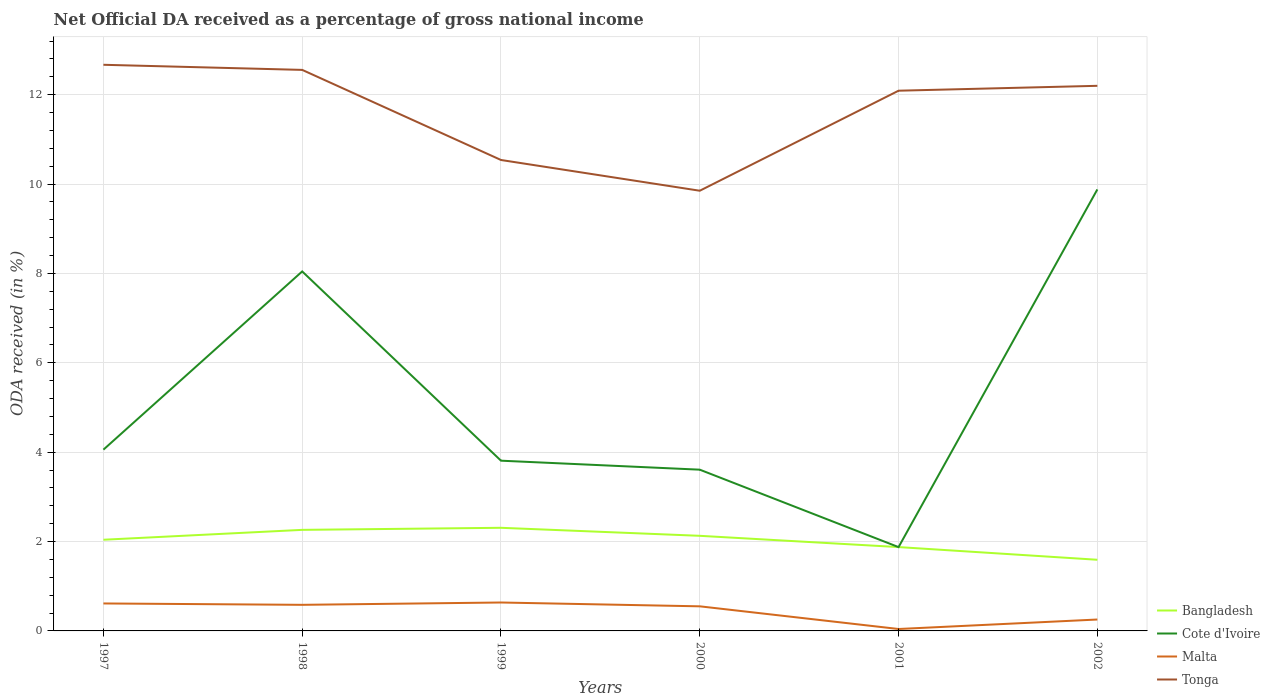Is the number of lines equal to the number of legend labels?
Make the answer very short. Yes. Across all years, what is the maximum net official DA received in Cote d'Ivoire?
Give a very brief answer. 1.88. In which year was the net official DA received in Cote d'Ivoire maximum?
Your response must be concise. 2001. What is the total net official DA received in Tonga in the graph?
Offer a terse response. 0.11. What is the difference between the highest and the second highest net official DA received in Malta?
Provide a succinct answer. 0.59. What is the difference between the highest and the lowest net official DA received in Tonga?
Give a very brief answer. 4. Is the net official DA received in Cote d'Ivoire strictly greater than the net official DA received in Tonga over the years?
Your answer should be very brief. Yes. How many lines are there?
Provide a succinct answer. 4. How many years are there in the graph?
Make the answer very short. 6. Are the values on the major ticks of Y-axis written in scientific E-notation?
Give a very brief answer. No. Does the graph contain any zero values?
Provide a succinct answer. No. How many legend labels are there?
Keep it short and to the point. 4. How are the legend labels stacked?
Provide a succinct answer. Vertical. What is the title of the graph?
Ensure brevity in your answer.  Net Official DA received as a percentage of gross national income. Does "Lao PDR" appear as one of the legend labels in the graph?
Offer a very short reply. No. What is the label or title of the X-axis?
Give a very brief answer. Years. What is the label or title of the Y-axis?
Your answer should be very brief. ODA received (in %). What is the ODA received (in %) of Bangladesh in 1997?
Offer a very short reply. 2.04. What is the ODA received (in %) in Cote d'Ivoire in 1997?
Provide a succinct answer. 4.06. What is the ODA received (in %) of Malta in 1997?
Provide a succinct answer. 0.61. What is the ODA received (in %) in Tonga in 1997?
Your answer should be very brief. 12.67. What is the ODA received (in %) of Bangladesh in 1998?
Provide a succinct answer. 2.26. What is the ODA received (in %) in Cote d'Ivoire in 1998?
Make the answer very short. 8.05. What is the ODA received (in %) of Malta in 1998?
Give a very brief answer. 0.58. What is the ODA received (in %) of Tonga in 1998?
Ensure brevity in your answer.  12.56. What is the ODA received (in %) in Bangladesh in 1999?
Ensure brevity in your answer.  2.31. What is the ODA received (in %) of Cote d'Ivoire in 1999?
Provide a short and direct response. 3.81. What is the ODA received (in %) in Malta in 1999?
Your answer should be compact. 0.64. What is the ODA received (in %) in Tonga in 1999?
Offer a very short reply. 10.54. What is the ODA received (in %) of Bangladesh in 2000?
Give a very brief answer. 2.13. What is the ODA received (in %) in Cote d'Ivoire in 2000?
Make the answer very short. 3.61. What is the ODA received (in %) of Malta in 2000?
Ensure brevity in your answer.  0.55. What is the ODA received (in %) of Tonga in 2000?
Your response must be concise. 9.85. What is the ODA received (in %) of Bangladesh in 2001?
Your answer should be very brief. 1.88. What is the ODA received (in %) in Cote d'Ivoire in 2001?
Make the answer very short. 1.88. What is the ODA received (in %) of Malta in 2001?
Your answer should be very brief. 0.04. What is the ODA received (in %) of Tonga in 2001?
Provide a short and direct response. 12.09. What is the ODA received (in %) of Bangladesh in 2002?
Your response must be concise. 1.59. What is the ODA received (in %) in Cote d'Ivoire in 2002?
Your answer should be compact. 9.88. What is the ODA received (in %) in Malta in 2002?
Give a very brief answer. 0.26. What is the ODA received (in %) of Tonga in 2002?
Your response must be concise. 12.2. Across all years, what is the maximum ODA received (in %) of Bangladesh?
Offer a very short reply. 2.31. Across all years, what is the maximum ODA received (in %) in Cote d'Ivoire?
Ensure brevity in your answer.  9.88. Across all years, what is the maximum ODA received (in %) of Malta?
Make the answer very short. 0.64. Across all years, what is the maximum ODA received (in %) in Tonga?
Make the answer very short. 12.67. Across all years, what is the minimum ODA received (in %) of Bangladesh?
Make the answer very short. 1.59. Across all years, what is the minimum ODA received (in %) in Cote d'Ivoire?
Ensure brevity in your answer.  1.88. Across all years, what is the minimum ODA received (in %) of Malta?
Keep it short and to the point. 0.04. Across all years, what is the minimum ODA received (in %) of Tonga?
Ensure brevity in your answer.  9.85. What is the total ODA received (in %) in Bangladesh in the graph?
Keep it short and to the point. 12.21. What is the total ODA received (in %) in Cote d'Ivoire in the graph?
Offer a very short reply. 31.28. What is the total ODA received (in %) in Malta in the graph?
Provide a short and direct response. 2.68. What is the total ODA received (in %) of Tonga in the graph?
Make the answer very short. 69.9. What is the difference between the ODA received (in %) of Bangladesh in 1997 and that in 1998?
Your answer should be compact. -0.22. What is the difference between the ODA received (in %) of Cote d'Ivoire in 1997 and that in 1998?
Provide a succinct answer. -3.99. What is the difference between the ODA received (in %) in Malta in 1997 and that in 1998?
Your response must be concise. 0.03. What is the difference between the ODA received (in %) in Tonga in 1997 and that in 1998?
Your answer should be compact. 0.11. What is the difference between the ODA received (in %) in Bangladesh in 1997 and that in 1999?
Offer a terse response. -0.27. What is the difference between the ODA received (in %) of Cote d'Ivoire in 1997 and that in 1999?
Give a very brief answer. 0.25. What is the difference between the ODA received (in %) in Malta in 1997 and that in 1999?
Offer a very short reply. -0.02. What is the difference between the ODA received (in %) in Tonga in 1997 and that in 1999?
Offer a very short reply. 2.13. What is the difference between the ODA received (in %) in Bangladesh in 1997 and that in 2000?
Offer a terse response. -0.09. What is the difference between the ODA received (in %) of Cote d'Ivoire in 1997 and that in 2000?
Give a very brief answer. 0.45. What is the difference between the ODA received (in %) of Malta in 1997 and that in 2000?
Make the answer very short. 0.06. What is the difference between the ODA received (in %) of Tonga in 1997 and that in 2000?
Give a very brief answer. 2.82. What is the difference between the ODA received (in %) in Bangladesh in 1997 and that in 2001?
Offer a very short reply. 0.16. What is the difference between the ODA received (in %) of Cote d'Ivoire in 1997 and that in 2001?
Offer a terse response. 2.18. What is the difference between the ODA received (in %) in Malta in 1997 and that in 2001?
Your response must be concise. 0.57. What is the difference between the ODA received (in %) of Tonga in 1997 and that in 2001?
Your response must be concise. 0.58. What is the difference between the ODA received (in %) of Bangladesh in 1997 and that in 2002?
Make the answer very short. 0.45. What is the difference between the ODA received (in %) of Cote d'Ivoire in 1997 and that in 2002?
Keep it short and to the point. -5.82. What is the difference between the ODA received (in %) in Malta in 1997 and that in 2002?
Keep it short and to the point. 0.36. What is the difference between the ODA received (in %) of Tonga in 1997 and that in 2002?
Provide a short and direct response. 0.47. What is the difference between the ODA received (in %) in Bangladesh in 1998 and that in 1999?
Provide a succinct answer. -0.05. What is the difference between the ODA received (in %) of Cote d'Ivoire in 1998 and that in 1999?
Give a very brief answer. 4.24. What is the difference between the ODA received (in %) in Malta in 1998 and that in 1999?
Make the answer very short. -0.05. What is the difference between the ODA received (in %) of Tonga in 1998 and that in 1999?
Keep it short and to the point. 2.02. What is the difference between the ODA received (in %) in Bangladesh in 1998 and that in 2000?
Your answer should be very brief. 0.13. What is the difference between the ODA received (in %) in Cote d'Ivoire in 1998 and that in 2000?
Your answer should be very brief. 4.44. What is the difference between the ODA received (in %) of Malta in 1998 and that in 2000?
Your response must be concise. 0.03. What is the difference between the ODA received (in %) of Tonga in 1998 and that in 2000?
Keep it short and to the point. 2.7. What is the difference between the ODA received (in %) of Bangladesh in 1998 and that in 2001?
Your answer should be compact. 0.39. What is the difference between the ODA received (in %) of Cote d'Ivoire in 1998 and that in 2001?
Offer a very short reply. 6.17. What is the difference between the ODA received (in %) of Malta in 1998 and that in 2001?
Provide a short and direct response. 0.54. What is the difference between the ODA received (in %) of Tonga in 1998 and that in 2001?
Make the answer very short. 0.47. What is the difference between the ODA received (in %) in Bangladesh in 1998 and that in 2002?
Provide a short and direct response. 0.67. What is the difference between the ODA received (in %) in Cote d'Ivoire in 1998 and that in 2002?
Give a very brief answer. -1.84. What is the difference between the ODA received (in %) of Malta in 1998 and that in 2002?
Provide a short and direct response. 0.33. What is the difference between the ODA received (in %) of Tonga in 1998 and that in 2002?
Make the answer very short. 0.36. What is the difference between the ODA received (in %) in Bangladesh in 1999 and that in 2000?
Your response must be concise. 0.18. What is the difference between the ODA received (in %) in Cote d'Ivoire in 1999 and that in 2000?
Keep it short and to the point. 0.2. What is the difference between the ODA received (in %) in Malta in 1999 and that in 2000?
Ensure brevity in your answer.  0.09. What is the difference between the ODA received (in %) of Tonga in 1999 and that in 2000?
Keep it short and to the point. 0.69. What is the difference between the ODA received (in %) in Bangladesh in 1999 and that in 2001?
Keep it short and to the point. 0.43. What is the difference between the ODA received (in %) in Cote d'Ivoire in 1999 and that in 2001?
Your answer should be compact. 1.93. What is the difference between the ODA received (in %) of Malta in 1999 and that in 2001?
Your answer should be very brief. 0.59. What is the difference between the ODA received (in %) of Tonga in 1999 and that in 2001?
Your answer should be very brief. -1.55. What is the difference between the ODA received (in %) of Bangladesh in 1999 and that in 2002?
Your response must be concise. 0.72. What is the difference between the ODA received (in %) of Cote d'Ivoire in 1999 and that in 2002?
Give a very brief answer. -6.07. What is the difference between the ODA received (in %) of Malta in 1999 and that in 2002?
Provide a short and direct response. 0.38. What is the difference between the ODA received (in %) in Tonga in 1999 and that in 2002?
Keep it short and to the point. -1.66. What is the difference between the ODA received (in %) in Bangladesh in 2000 and that in 2001?
Provide a short and direct response. 0.25. What is the difference between the ODA received (in %) in Cote d'Ivoire in 2000 and that in 2001?
Offer a terse response. 1.73. What is the difference between the ODA received (in %) of Malta in 2000 and that in 2001?
Your response must be concise. 0.51. What is the difference between the ODA received (in %) in Tonga in 2000 and that in 2001?
Provide a succinct answer. -2.24. What is the difference between the ODA received (in %) in Bangladesh in 2000 and that in 2002?
Provide a short and direct response. 0.54. What is the difference between the ODA received (in %) in Cote d'Ivoire in 2000 and that in 2002?
Ensure brevity in your answer.  -6.27. What is the difference between the ODA received (in %) of Malta in 2000 and that in 2002?
Give a very brief answer. 0.3. What is the difference between the ODA received (in %) in Tonga in 2000 and that in 2002?
Offer a terse response. -2.35. What is the difference between the ODA received (in %) in Bangladesh in 2001 and that in 2002?
Your response must be concise. 0.28. What is the difference between the ODA received (in %) of Cote d'Ivoire in 2001 and that in 2002?
Provide a short and direct response. -8. What is the difference between the ODA received (in %) of Malta in 2001 and that in 2002?
Give a very brief answer. -0.21. What is the difference between the ODA received (in %) in Tonga in 2001 and that in 2002?
Your answer should be very brief. -0.11. What is the difference between the ODA received (in %) in Bangladesh in 1997 and the ODA received (in %) in Cote d'Ivoire in 1998?
Offer a very short reply. -6. What is the difference between the ODA received (in %) of Bangladesh in 1997 and the ODA received (in %) of Malta in 1998?
Your response must be concise. 1.46. What is the difference between the ODA received (in %) of Bangladesh in 1997 and the ODA received (in %) of Tonga in 1998?
Offer a terse response. -10.52. What is the difference between the ODA received (in %) in Cote d'Ivoire in 1997 and the ODA received (in %) in Malta in 1998?
Ensure brevity in your answer.  3.47. What is the difference between the ODA received (in %) of Cote d'Ivoire in 1997 and the ODA received (in %) of Tonga in 1998?
Provide a short and direct response. -8.5. What is the difference between the ODA received (in %) in Malta in 1997 and the ODA received (in %) in Tonga in 1998?
Give a very brief answer. -11.94. What is the difference between the ODA received (in %) of Bangladesh in 1997 and the ODA received (in %) of Cote d'Ivoire in 1999?
Your answer should be very brief. -1.77. What is the difference between the ODA received (in %) of Bangladesh in 1997 and the ODA received (in %) of Malta in 1999?
Provide a succinct answer. 1.4. What is the difference between the ODA received (in %) in Bangladesh in 1997 and the ODA received (in %) in Tonga in 1999?
Offer a terse response. -8.5. What is the difference between the ODA received (in %) in Cote d'Ivoire in 1997 and the ODA received (in %) in Malta in 1999?
Give a very brief answer. 3.42. What is the difference between the ODA received (in %) in Cote d'Ivoire in 1997 and the ODA received (in %) in Tonga in 1999?
Your response must be concise. -6.48. What is the difference between the ODA received (in %) in Malta in 1997 and the ODA received (in %) in Tonga in 1999?
Give a very brief answer. -9.92. What is the difference between the ODA received (in %) of Bangladesh in 1997 and the ODA received (in %) of Cote d'Ivoire in 2000?
Offer a terse response. -1.57. What is the difference between the ODA received (in %) in Bangladesh in 1997 and the ODA received (in %) in Malta in 2000?
Your answer should be compact. 1.49. What is the difference between the ODA received (in %) in Bangladesh in 1997 and the ODA received (in %) in Tonga in 2000?
Your response must be concise. -7.81. What is the difference between the ODA received (in %) in Cote d'Ivoire in 1997 and the ODA received (in %) in Malta in 2000?
Offer a terse response. 3.51. What is the difference between the ODA received (in %) in Cote d'Ivoire in 1997 and the ODA received (in %) in Tonga in 2000?
Provide a short and direct response. -5.79. What is the difference between the ODA received (in %) of Malta in 1997 and the ODA received (in %) of Tonga in 2000?
Make the answer very short. -9.24. What is the difference between the ODA received (in %) in Bangladesh in 1997 and the ODA received (in %) in Cote d'Ivoire in 2001?
Make the answer very short. 0.16. What is the difference between the ODA received (in %) of Bangladesh in 1997 and the ODA received (in %) of Malta in 2001?
Make the answer very short. 2. What is the difference between the ODA received (in %) of Bangladesh in 1997 and the ODA received (in %) of Tonga in 2001?
Offer a very short reply. -10.05. What is the difference between the ODA received (in %) in Cote d'Ivoire in 1997 and the ODA received (in %) in Malta in 2001?
Provide a short and direct response. 4.01. What is the difference between the ODA received (in %) in Cote d'Ivoire in 1997 and the ODA received (in %) in Tonga in 2001?
Your answer should be very brief. -8.03. What is the difference between the ODA received (in %) of Malta in 1997 and the ODA received (in %) of Tonga in 2001?
Ensure brevity in your answer.  -11.47. What is the difference between the ODA received (in %) of Bangladesh in 1997 and the ODA received (in %) of Cote d'Ivoire in 2002?
Offer a terse response. -7.84. What is the difference between the ODA received (in %) of Bangladesh in 1997 and the ODA received (in %) of Malta in 2002?
Your answer should be very brief. 1.79. What is the difference between the ODA received (in %) of Bangladesh in 1997 and the ODA received (in %) of Tonga in 2002?
Offer a terse response. -10.16. What is the difference between the ODA received (in %) in Cote d'Ivoire in 1997 and the ODA received (in %) in Malta in 2002?
Your answer should be very brief. 3.8. What is the difference between the ODA received (in %) in Cote d'Ivoire in 1997 and the ODA received (in %) in Tonga in 2002?
Keep it short and to the point. -8.14. What is the difference between the ODA received (in %) of Malta in 1997 and the ODA received (in %) of Tonga in 2002?
Make the answer very short. -11.58. What is the difference between the ODA received (in %) of Bangladesh in 1998 and the ODA received (in %) of Cote d'Ivoire in 1999?
Offer a very short reply. -1.55. What is the difference between the ODA received (in %) of Bangladesh in 1998 and the ODA received (in %) of Malta in 1999?
Your answer should be very brief. 1.63. What is the difference between the ODA received (in %) in Bangladesh in 1998 and the ODA received (in %) in Tonga in 1999?
Provide a short and direct response. -8.28. What is the difference between the ODA received (in %) of Cote d'Ivoire in 1998 and the ODA received (in %) of Malta in 1999?
Provide a succinct answer. 7.41. What is the difference between the ODA received (in %) of Cote d'Ivoire in 1998 and the ODA received (in %) of Tonga in 1999?
Make the answer very short. -2.49. What is the difference between the ODA received (in %) of Malta in 1998 and the ODA received (in %) of Tonga in 1999?
Offer a terse response. -9.96. What is the difference between the ODA received (in %) of Bangladesh in 1998 and the ODA received (in %) of Cote d'Ivoire in 2000?
Make the answer very short. -1.35. What is the difference between the ODA received (in %) of Bangladesh in 1998 and the ODA received (in %) of Malta in 2000?
Your answer should be very brief. 1.71. What is the difference between the ODA received (in %) of Bangladesh in 1998 and the ODA received (in %) of Tonga in 2000?
Keep it short and to the point. -7.59. What is the difference between the ODA received (in %) of Cote d'Ivoire in 1998 and the ODA received (in %) of Malta in 2000?
Ensure brevity in your answer.  7.49. What is the difference between the ODA received (in %) of Cote d'Ivoire in 1998 and the ODA received (in %) of Tonga in 2000?
Your response must be concise. -1.81. What is the difference between the ODA received (in %) of Malta in 1998 and the ODA received (in %) of Tonga in 2000?
Your answer should be compact. -9.27. What is the difference between the ODA received (in %) of Bangladesh in 1998 and the ODA received (in %) of Cote d'Ivoire in 2001?
Make the answer very short. 0.39. What is the difference between the ODA received (in %) in Bangladesh in 1998 and the ODA received (in %) in Malta in 2001?
Offer a very short reply. 2.22. What is the difference between the ODA received (in %) in Bangladesh in 1998 and the ODA received (in %) in Tonga in 2001?
Your answer should be compact. -9.83. What is the difference between the ODA received (in %) of Cote d'Ivoire in 1998 and the ODA received (in %) of Malta in 2001?
Offer a terse response. 8. What is the difference between the ODA received (in %) in Cote d'Ivoire in 1998 and the ODA received (in %) in Tonga in 2001?
Offer a terse response. -4.04. What is the difference between the ODA received (in %) in Malta in 1998 and the ODA received (in %) in Tonga in 2001?
Ensure brevity in your answer.  -11.51. What is the difference between the ODA received (in %) in Bangladesh in 1998 and the ODA received (in %) in Cote d'Ivoire in 2002?
Your answer should be very brief. -7.62. What is the difference between the ODA received (in %) of Bangladesh in 1998 and the ODA received (in %) of Malta in 2002?
Offer a terse response. 2.01. What is the difference between the ODA received (in %) of Bangladesh in 1998 and the ODA received (in %) of Tonga in 2002?
Your response must be concise. -9.94. What is the difference between the ODA received (in %) in Cote d'Ivoire in 1998 and the ODA received (in %) in Malta in 2002?
Provide a short and direct response. 7.79. What is the difference between the ODA received (in %) of Cote d'Ivoire in 1998 and the ODA received (in %) of Tonga in 2002?
Offer a terse response. -4.15. What is the difference between the ODA received (in %) of Malta in 1998 and the ODA received (in %) of Tonga in 2002?
Keep it short and to the point. -11.62. What is the difference between the ODA received (in %) in Bangladesh in 1999 and the ODA received (in %) in Cote d'Ivoire in 2000?
Give a very brief answer. -1.3. What is the difference between the ODA received (in %) in Bangladesh in 1999 and the ODA received (in %) in Malta in 2000?
Give a very brief answer. 1.76. What is the difference between the ODA received (in %) in Bangladesh in 1999 and the ODA received (in %) in Tonga in 2000?
Give a very brief answer. -7.54. What is the difference between the ODA received (in %) in Cote d'Ivoire in 1999 and the ODA received (in %) in Malta in 2000?
Provide a succinct answer. 3.26. What is the difference between the ODA received (in %) in Cote d'Ivoire in 1999 and the ODA received (in %) in Tonga in 2000?
Ensure brevity in your answer.  -6.04. What is the difference between the ODA received (in %) in Malta in 1999 and the ODA received (in %) in Tonga in 2000?
Offer a terse response. -9.22. What is the difference between the ODA received (in %) of Bangladesh in 1999 and the ODA received (in %) of Cote d'Ivoire in 2001?
Give a very brief answer. 0.43. What is the difference between the ODA received (in %) in Bangladesh in 1999 and the ODA received (in %) in Malta in 2001?
Your answer should be very brief. 2.26. What is the difference between the ODA received (in %) in Bangladesh in 1999 and the ODA received (in %) in Tonga in 2001?
Your response must be concise. -9.78. What is the difference between the ODA received (in %) in Cote d'Ivoire in 1999 and the ODA received (in %) in Malta in 2001?
Provide a short and direct response. 3.77. What is the difference between the ODA received (in %) in Cote d'Ivoire in 1999 and the ODA received (in %) in Tonga in 2001?
Keep it short and to the point. -8.28. What is the difference between the ODA received (in %) of Malta in 1999 and the ODA received (in %) of Tonga in 2001?
Offer a very short reply. -11.45. What is the difference between the ODA received (in %) in Bangladesh in 1999 and the ODA received (in %) in Cote d'Ivoire in 2002?
Offer a terse response. -7.57. What is the difference between the ODA received (in %) of Bangladesh in 1999 and the ODA received (in %) of Malta in 2002?
Provide a succinct answer. 2.05. What is the difference between the ODA received (in %) in Bangladesh in 1999 and the ODA received (in %) in Tonga in 2002?
Ensure brevity in your answer.  -9.89. What is the difference between the ODA received (in %) in Cote d'Ivoire in 1999 and the ODA received (in %) in Malta in 2002?
Your response must be concise. 3.55. What is the difference between the ODA received (in %) of Cote d'Ivoire in 1999 and the ODA received (in %) of Tonga in 2002?
Offer a very short reply. -8.39. What is the difference between the ODA received (in %) of Malta in 1999 and the ODA received (in %) of Tonga in 2002?
Your answer should be very brief. -11.56. What is the difference between the ODA received (in %) in Bangladesh in 2000 and the ODA received (in %) in Cote d'Ivoire in 2001?
Your answer should be compact. 0.25. What is the difference between the ODA received (in %) of Bangladesh in 2000 and the ODA received (in %) of Malta in 2001?
Keep it short and to the point. 2.09. What is the difference between the ODA received (in %) of Bangladesh in 2000 and the ODA received (in %) of Tonga in 2001?
Offer a very short reply. -9.96. What is the difference between the ODA received (in %) in Cote d'Ivoire in 2000 and the ODA received (in %) in Malta in 2001?
Provide a succinct answer. 3.57. What is the difference between the ODA received (in %) of Cote d'Ivoire in 2000 and the ODA received (in %) of Tonga in 2001?
Your answer should be very brief. -8.48. What is the difference between the ODA received (in %) of Malta in 2000 and the ODA received (in %) of Tonga in 2001?
Give a very brief answer. -11.54. What is the difference between the ODA received (in %) in Bangladesh in 2000 and the ODA received (in %) in Cote d'Ivoire in 2002?
Your response must be concise. -7.75. What is the difference between the ODA received (in %) in Bangladesh in 2000 and the ODA received (in %) in Malta in 2002?
Ensure brevity in your answer.  1.87. What is the difference between the ODA received (in %) of Bangladesh in 2000 and the ODA received (in %) of Tonga in 2002?
Provide a short and direct response. -10.07. What is the difference between the ODA received (in %) in Cote d'Ivoire in 2000 and the ODA received (in %) in Malta in 2002?
Offer a very short reply. 3.35. What is the difference between the ODA received (in %) in Cote d'Ivoire in 2000 and the ODA received (in %) in Tonga in 2002?
Ensure brevity in your answer.  -8.59. What is the difference between the ODA received (in %) of Malta in 2000 and the ODA received (in %) of Tonga in 2002?
Offer a very short reply. -11.65. What is the difference between the ODA received (in %) of Bangladesh in 2001 and the ODA received (in %) of Cote d'Ivoire in 2002?
Offer a terse response. -8. What is the difference between the ODA received (in %) in Bangladesh in 2001 and the ODA received (in %) in Malta in 2002?
Provide a short and direct response. 1.62. What is the difference between the ODA received (in %) in Bangladesh in 2001 and the ODA received (in %) in Tonga in 2002?
Offer a very short reply. -10.32. What is the difference between the ODA received (in %) in Cote d'Ivoire in 2001 and the ODA received (in %) in Malta in 2002?
Give a very brief answer. 1.62. What is the difference between the ODA received (in %) in Cote d'Ivoire in 2001 and the ODA received (in %) in Tonga in 2002?
Your answer should be very brief. -10.32. What is the difference between the ODA received (in %) in Malta in 2001 and the ODA received (in %) in Tonga in 2002?
Your answer should be very brief. -12.16. What is the average ODA received (in %) in Bangladesh per year?
Offer a terse response. 2.03. What is the average ODA received (in %) in Cote d'Ivoire per year?
Offer a terse response. 5.21. What is the average ODA received (in %) in Malta per year?
Your answer should be very brief. 0.45. What is the average ODA received (in %) of Tonga per year?
Your answer should be compact. 11.65. In the year 1997, what is the difference between the ODA received (in %) in Bangladesh and ODA received (in %) in Cote d'Ivoire?
Keep it short and to the point. -2.02. In the year 1997, what is the difference between the ODA received (in %) in Bangladesh and ODA received (in %) in Malta?
Your answer should be very brief. 1.43. In the year 1997, what is the difference between the ODA received (in %) in Bangladesh and ODA received (in %) in Tonga?
Your answer should be very brief. -10.63. In the year 1997, what is the difference between the ODA received (in %) of Cote d'Ivoire and ODA received (in %) of Malta?
Your answer should be very brief. 3.44. In the year 1997, what is the difference between the ODA received (in %) of Cote d'Ivoire and ODA received (in %) of Tonga?
Provide a succinct answer. -8.61. In the year 1997, what is the difference between the ODA received (in %) in Malta and ODA received (in %) in Tonga?
Make the answer very short. -12.05. In the year 1998, what is the difference between the ODA received (in %) of Bangladesh and ODA received (in %) of Cote d'Ivoire?
Ensure brevity in your answer.  -5.78. In the year 1998, what is the difference between the ODA received (in %) in Bangladesh and ODA received (in %) in Malta?
Offer a very short reply. 1.68. In the year 1998, what is the difference between the ODA received (in %) of Bangladesh and ODA received (in %) of Tonga?
Keep it short and to the point. -10.29. In the year 1998, what is the difference between the ODA received (in %) in Cote d'Ivoire and ODA received (in %) in Malta?
Provide a succinct answer. 7.46. In the year 1998, what is the difference between the ODA received (in %) of Cote d'Ivoire and ODA received (in %) of Tonga?
Offer a very short reply. -4.51. In the year 1998, what is the difference between the ODA received (in %) of Malta and ODA received (in %) of Tonga?
Your answer should be compact. -11.97. In the year 1999, what is the difference between the ODA received (in %) of Bangladesh and ODA received (in %) of Cote d'Ivoire?
Provide a short and direct response. -1.5. In the year 1999, what is the difference between the ODA received (in %) of Bangladesh and ODA received (in %) of Malta?
Keep it short and to the point. 1.67. In the year 1999, what is the difference between the ODA received (in %) of Bangladesh and ODA received (in %) of Tonga?
Ensure brevity in your answer.  -8.23. In the year 1999, what is the difference between the ODA received (in %) of Cote d'Ivoire and ODA received (in %) of Malta?
Keep it short and to the point. 3.17. In the year 1999, what is the difference between the ODA received (in %) in Cote d'Ivoire and ODA received (in %) in Tonga?
Offer a very short reply. -6.73. In the year 1999, what is the difference between the ODA received (in %) in Malta and ODA received (in %) in Tonga?
Offer a terse response. -9.9. In the year 2000, what is the difference between the ODA received (in %) in Bangladesh and ODA received (in %) in Cote d'Ivoire?
Your answer should be very brief. -1.48. In the year 2000, what is the difference between the ODA received (in %) in Bangladesh and ODA received (in %) in Malta?
Ensure brevity in your answer.  1.58. In the year 2000, what is the difference between the ODA received (in %) in Bangladesh and ODA received (in %) in Tonga?
Provide a short and direct response. -7.72. In the year 2000, what is the difference between the ODA received (in %) in Cote d'Ivoire and ODA received (in %) in Malta?
Offer a very short reply. 3.06. In the year 2000, what is the difference between the ODA received (in %) in Cote d'Ivoire and ODA received (in %) in Tonga?
Your answer should be very brief. -6.24. In the year 2000, what is the difference between the ODA received (in %) of Malta and ODA received (in %) of Tonga?
Your response must be concise. -9.3. In the year 2001, what is the difference between the ODA received (in %) of Bangladesh and ODA received (in %) of Cote d'Ivoire?
Provide a succinct answer. 0. In the year 2001, what is the difference between the ODA received (in %) of Bangladesh and ODA received (in %) of Malta?
Your response must be concise. 1.83. In the year 2001, what is the difference between the ODA received (in %) in Bangladesh and ODA received (in %) in Tonga?
Your answer should be very brief. -10.21. In the year 2001, what is the difference between the ODA received (in %) in Cote d'Ivoire and ODA received (in %) in Malta?
Make the answer very short. 1.83. In the year 2001, what is the difference between the ODA received (in %) in Cote d'Ivoire and ODA received (in %) in Tonga?
Your answer should be very brief. -10.21. In the year 2001, what is the difference between the ODA received (in %) of Malta and ODA received (in %) of Tonga?
Offer a very short reply. -12.05. In the year 2002, what is the difference between the ODA received (in %) in Bangladesh and ODA received (in %) in Cote d'Ivoire?
Offer a terse response. -8.29. In the year 2002, what is the difference between the ODA received (in %) in Bangladesh and ODA received (in %) in Malta?
Your answer should be very brief. 1.34. In the year 2002, what is the difference between the ODA received (in %) in Bangladesh and ODA received (in %) in Tonga?
Offer a very short reply. -10.61. In the year 2002, what is the difference between the ODA received (in %) of Cote d'Ivoire and ODA received (in %) of Malta?
Offer a terse response. 9.62. In the year 2002, what is the difference between the ODA received (in %) of Cote d'Ivoire and ODA received (in %) of Tonga?
Provide a succinct answer. -2.32. In the year 2002, what is the difference between the ODA received (in %) in Malta and ODA received (in %) in Tonga?
Your answer should be compact. -11.94. What is the ratio of the ODA received (in %) in Bangladesh in 1997 to that in 1998?
Provide a short and direct response. 0.9. What is the ratio of the ODA received (in %) in Cote d'Ivoire in 1997 to that in 1998?
Keep it short and to the point. 0.5. What is the ratio of the ODA received (in %) of Malta in 1997 to that in 1998?
Provide a succinct answer. 1.05. What is the ratio of the ODA received (in %) in Tonga in 1997 to that in 1998?
Offer a very short reply. 1.01. What is the ratio of the ODA received (in %) of Bangladesh in 1997 to that in 1999?
Your answer should be very brief. 0.88. What is the ratio of the ODA received (in %) in Cote d'Ivoire in 1997 to that in 1999?
Offer a very short reply. 1.06. What is the ratio of the ODA received (in %) in Malta in 1997 to that in 1999?
Give a very brief answer. 0.97. What is the ratio of the ODA received (in %) in Tonga in 1997 to that in 1999?
Provide a succinct answer. 1.2. What is the ratio of the ODA received (in %) of Bangladesh in 1997 to that in 2000?
Provide a short and direct response. 0.96. What is the ratio of the ODA received (in %) of Cote d'Ivoire in 1997 to that in 2000?
Offer a very short reply. 1.12. What is the ratio of the ODA received (in %) of Malta in 1997 to that in 2000?
Offer a very short reply. 1.12. What is the ratio of the ODA received (in %) in Tonga in 1997 to that in 2000?
Your response must be concise. 1.29. What is the ratio of the ODA received (in %) of Bangladesh in 1997 to that in 2001?
Offer a very short reply. 1.09. What is the ratio of the ODA received (in %) of Cote d'Ivoire in 1997 to that in 2001?
Your answer should be compact. 2.16. What is the ratio of the ODA received (in %) in Malta in 1997 to that in 2001?
Give a very brief answer. 14.31. What is the ratio of the ODA received (in %) in Tonga in 1997 to that in 2001?
Offer a very short reply. 1.05. What is the ratio of the ODA received (in %) of Bangladesh in 1997 to that in 2002?
Make the answer very short. 1.28. What is the ratio of the ODA received (in %) in Cote d'Ivoire in 1997 to that in 2002?
Provide a short and direct response. 0.41. What is the ratio of the ODA received (in %) in Malta in 1997 to that in 2002?
Provide a short and direct response. 2.41. What is the ratio of the ODA received (in %) of Tonga in 1997 to that in 2002?
Make the answer very short. 1.04. What is the ratio of the ODA received (in %) of Bangladesh in 1998 to that in 1999?
Give a very brief answer. 0.98. What is the ratio of the ODA received (in %) of Cote d'Ivoire in 1998 to that in 1999?
Offer a terse response. 2.11. What is the ratio of the ODA received (in %) in Malta in 1998 to that in 1999?
Give a very brief answer. 0.92. What is the ratio of the ODA received (in %) of Tonga in 1998 to that in 1999?
Your answer should be compact. 1.19. What is the ratio of the ODA received (in %) of Bangladesh in 1998 to that in 2000?
Offer a very short reply. 1.06. What is the ratio of the ODA received (in %) in Cote d'Ivoire in 1998 to that in 2000?
Offer a terse response. 2.23. What is the ratio of the ODA received (in %) of Malta in 1998 to that in 2000?
Your answer should be compact. 1.06. What is the ratio of the ODA received (in %) of Tonga in 1998 to that in 2000?
Provide a succinct answer. 1.27. What is the ratio of the ODA received (in %) of Bangladesh in 1998 to that in 2001?
Offer a very short reply. 1.21. What is the ratio of the ODA received (in %) of Cote d'Ivoire in 1998 to that in 2001?
Offer a very short reply. 4.29. What is the ratio of the ODA received (in %) in Malta in 1998 to that in 2001?
Offer a terse response. 13.59. What is the ratio of the ODA received (in %) of Bangladesh in 1998 to that in 2002?
Provide a succinct answer. 1.42. What is the ratio of the ODA received (in %) in Cote d'Ivoire in 1998 to that in 2002?
Your response must be concise. 0.81. What is the ratio of the ODA received (in %) of Malta in 1998 to that in 2002?
Provide a succinct answer. 2.29. What is the ratio of the ODA received (in %) in Tonga in 1998 to that in 2002?
Provide a short and direct response. 1.03. What is the ratio of the ODA received (in %) in Bangladesh in 1999 to that in 2000?
Make the answer very short. 1.08. What is the ratio of the ODA received (in %) in Cote d'Ivoire in 1999 to that in 2000?
Your answer should be very brief. 1.06. What is the ratio of the ODA received (in %) in Malta in 1999 to that in 2000?
Offer a terse response. 1.16. What is the ratio of the ODA received (in %) in Tonga in 1999 to that in 2000?
Your answer should be very brief. 1.07. What is the ratio of the ODA received (in %) in Bangladesh in 1999 to that in 2001?
Your response must be concise. 1.23. What is the ratio of the ODA received (in %) of Cote d'Ivoire in 1999 to that in 2001?
Your answer should be very brief. 2.03. What is the ratio of the ODA received (in %) of Malta in 1999 to that in 2001?
Offer a terse response. 14.8. What is the ratio of the ODA received (in %) of Tonga in 1999 to that in 2001?
Keep it short and to the point. 0.87. What is the ratio of the ODA received (in %) of Bangladesh in 1999 to that in 2002?
Provide a short and direct response. 1.45. What is the ratio of the ODA received (in %) in Cote d'Ivoire in 1999 to that in 2002?
Offer a terse response. 0.39. What is the ratio of the ODA received (in %) of Malta in 1999 to that in 2002?
Give a very brief answer. 2.49. What is the ratio of the ODA received (in %) of Tonga in 1999 to that in 2002?
Keep it short and to the point. 0.86. What is the ratio of the ODA received (in %) in Bangladesh in 2000 to that in 2001?
Your response must be concise. 1.13. What is the ratio of the ODA received (in %) in Cote d'Ivoire in 2000 to that in 2001?
Provide a short and direct response. 1.92. What is the ratio of the ODA received (in %) in Malta in 2000 to that in 2001?
Keep it short and to the point. 12.81. What is the ratio of the ODA received (in %) of Tonga in 2000 to that in 2001?
Provide a succinct answer. 0.81. What is the ratio of the ODA received (in %) of Bangladesh in 2000 to that in 2002?
Give a very brief answer. 1.34. What is the ratio of the ODA received (in %) of Cote d'Ivoire in 2000 to that in 2002?
Keep it short and to the point. 0.37. What is the ratio of the ODA received (in %) in Malta in 2000 to that in 2002?
Offer a very short reply. 2.16. What is the ratio of the ODA received (in %) of Tonga in 2000 to that in 2002?
Ensure brevity in your answer.  0.81. What is the ratio of the ODA received (in %) of Bangladesh in 2001 to that in 2002?
Your answer should be compact. 1.18. What is the ratio of the ODA received (in %) in Cote d'Ivoire in 2001 to that in 2002?
Provide a succinct answer. 0.19. What is the ratio of the ODA received (in %) of Malta in 2001 to that in 2002?
Keep it short and to the point. 0.17. What is the difference between the highest and the second highest ODA received (in %) in Bangladesh?
Offer a very short reply. 0.05. What is the difference between the highest and the second highest ODA received (in %) of Cote d'Ivoire?
Your answer should be compact. 1.84. What is the difference between the highest and the second highest ODA received (in %) in Malta?
Offer a very short reply. 0.02. What is the difference between the highest and the second highest ODA received (in %) in Tonga?
Offer a terse response. 0.11. What is the difference between the highest and the lowest ODA received (in %) in Bangladesh?
Provide a short and direct response. 0.72. What is the difference between the highest and the lowest ODA received (in %) in Cote d'Ivoire?
Give a very brief answer. 8. What is the difference between the highest and the lowest ODA received (in %) of Malta?
Make the answer very short. 0.59. What is the difference between the highest and the lowest ODA received (in %) in Tonga?
Your answer should be compact. 2.82. 